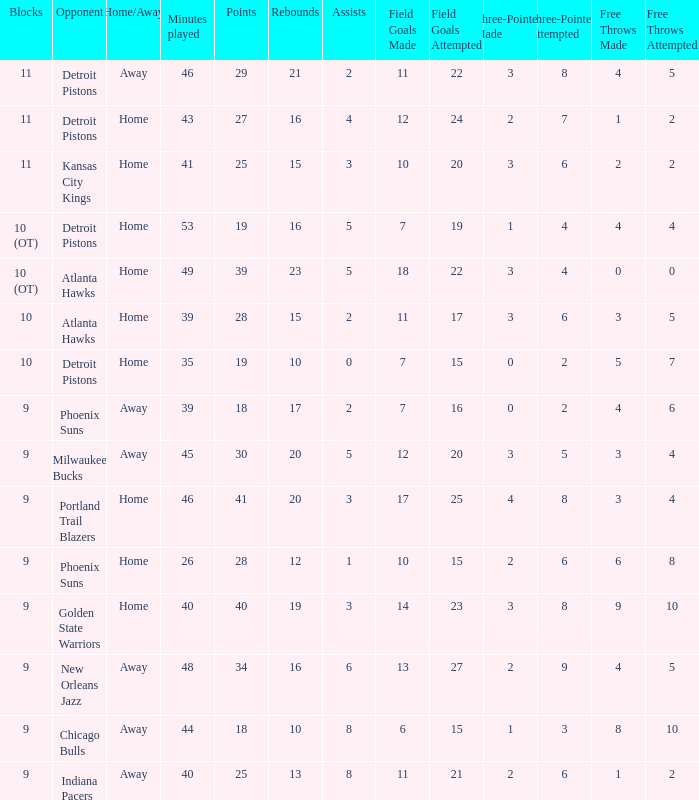How many minutes were played when there were 18 points and the opponent was Chicago Bulls? 1.0. 